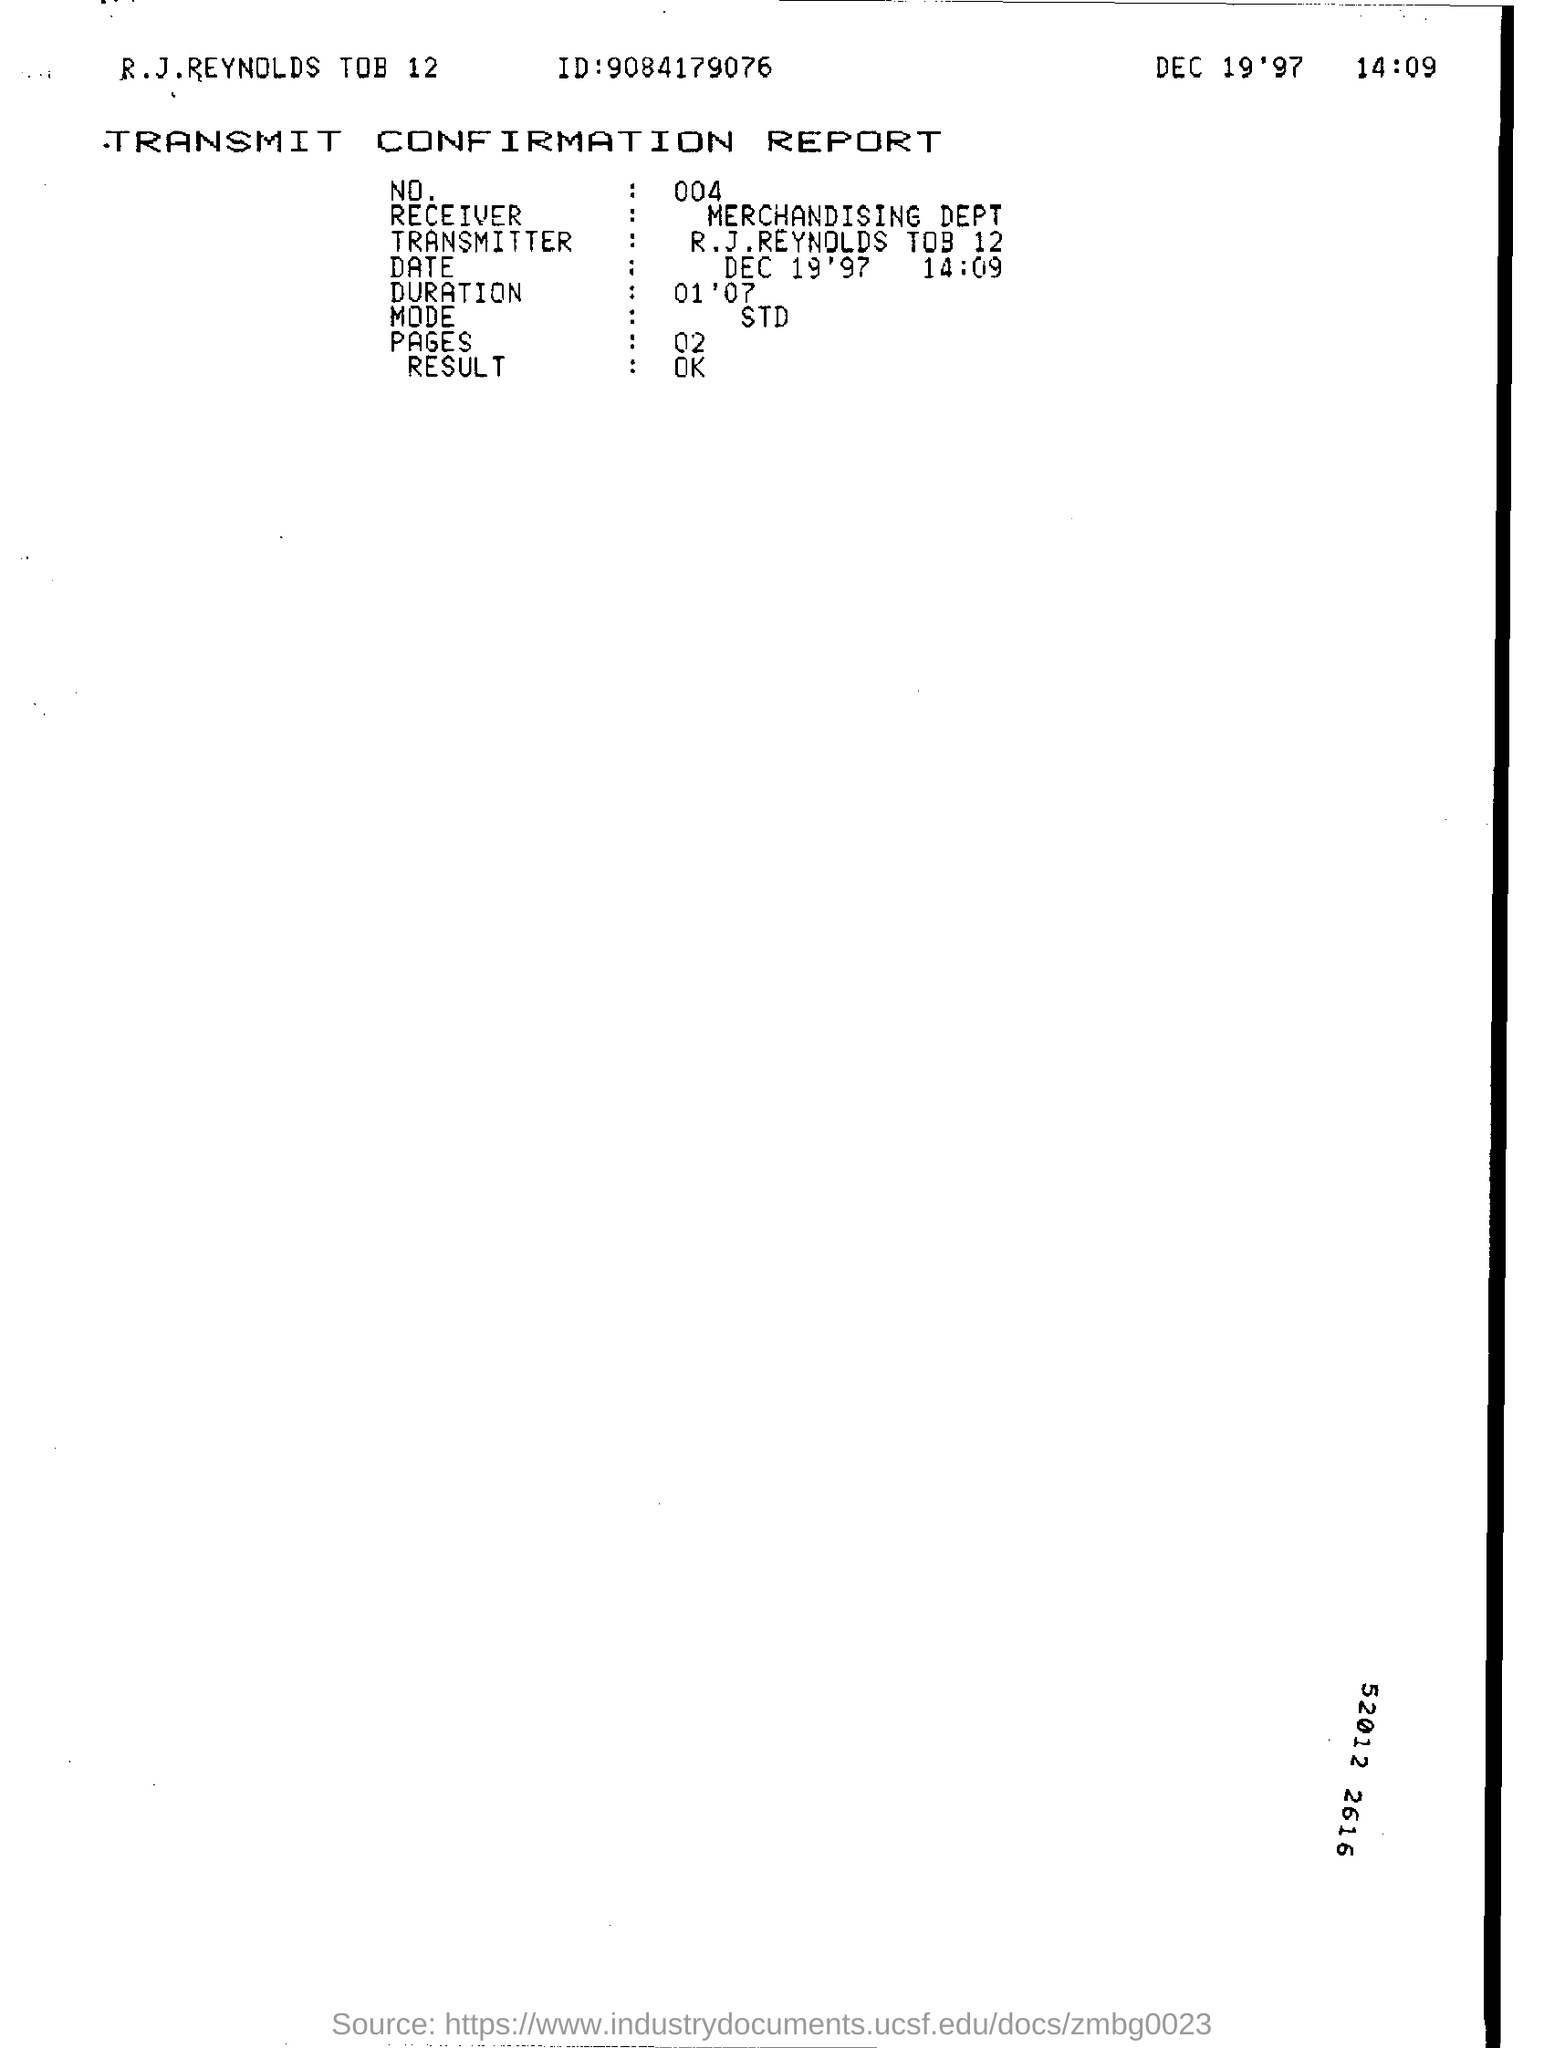List a handful of essential elements in this visual. An individual identification number is a unique numerical sequence assigned to a specific person, typically for the purpose of identification or record-keeping. An example of an individual identification number is "9084179076. There are two pages. The Merchandising Department is the receiver. 